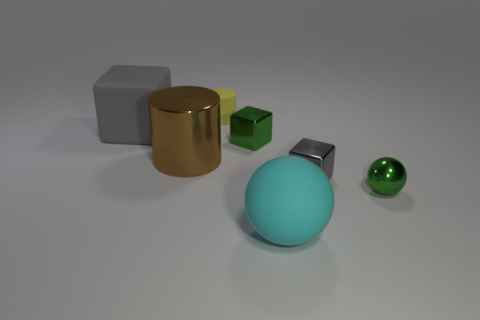What number of small things are cylinders or metal balls?
Your response must be concise. 2. The large sphere that is the same material as the yellow object is what color?
Give a very brief answer. Cyan. How many tiny yellow cylinders are made of the same material as the tiny gray object?
Offer a very short reply. 0. There is a gray object that is left of the big brown shiny cylinder; is its size the same as the gray thing to the right of the yellow cylinder?
Offer a terse response. No. There is a tiny object left of the tiny green metallic object behind the gray shiny cube; what is its material?
Keep it short and to the point. Rubber. Is the number of big brown metal things that are behind the big cube less than the number of green things that are left of the tiny rubber thing?
Your answer should be very brief. No. What is the material of the small cube that is the same color as the big cube?
Give a very brief answer. Metal. Are there any other things that have the same shape as the big brown shiny thing?
Offer a very short reply. Yes. What is the gray thing that is to the left of the small matte object made of?
Your response must be concise. Rubber. Are there any other things that are the same size as the green metal block?
Your answer should be very brief. Yes. 